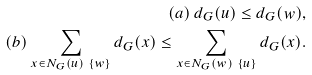<formula> <loc_0><loc_0><loc_500><loc_500>( a ) \, d _ { G } ( u ) \leq d _ { G } ( w ) , \\ ( b ) \sum _ { x \in N _ { G } ( u ) \ \{ w \} } d _ { G } ( x ) \leq \sum _ { x \in N _ { G } ( w ) \ \{ u \} } d _ { G } ( x ) . & &</formula> 